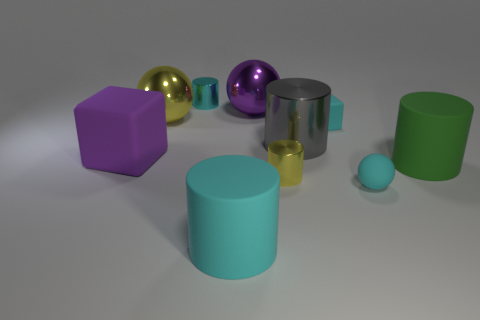What is the material of the cyan cylinder that is in front of the block to the left of the big rubber thing in front of the small yellow metal cylinder?
Your answer should be very brief. Rubber. How many other things are there of the same shape as the large green matte thing?
Offer a terse response. 4. There is a big matte cylinder behind the yellow metallic cylinder; what color is it?
Your answer should be very brief. Green. There is a small cylinder that is behind the large matte object on the left side of the small cyan cylinder; what number of big objects are to the right of it?
Your answer should be compact. 4. What number of large balls are on the right side of the cyan rubber object that is behind the purple cube?
Offer a terse response. 0. There is a large green matte cylinder; how many large green objects are right of it?
Keep it short and to the point. 0. How many other objects are there of the same size as the cyan ball?
Offer a very short reply. 3. There is a cyan thing that is the same shape as the purple matte object; what size is it?
Make the answer very short. Small. There is a yellow metallic thing that is in front of the large purple matte object; what shape is it?
Provide a short and direct response. Cylinder. What is the color of the rubber cylinder that is to the left of the cyan matte object behind the tiny cyan ball?
Your answer should be very brief. Cyan. 